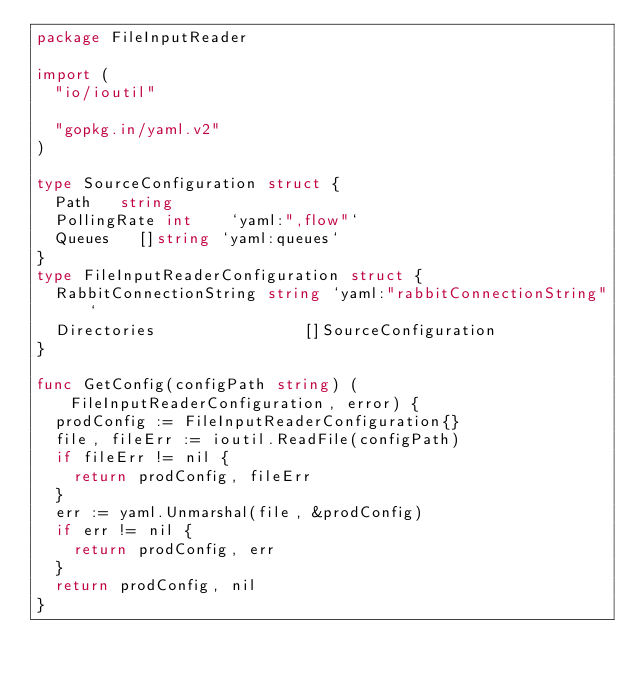<code> <loc_0><loc_0><loc_500><loc_500><_Go_>package FileInputReader

import (
	"io/ioutil"

	"gopkg.in/yaml.v2"
)

type SourceConfiguration struct {
	Path   string
	PollingRate int    `yaml:",flow"`
	Queues   []string `yaml:queues`
}
type FileInputReaderConfiguration struct {
	RabbitConnectionString string `yaml:"rabbitConnectionString"`
	Directories                []SourceConfiguration
}

func GetConfig(configPath string) (FileInputReaderConfiguration, error) {
	prodConfig := FileInputReaderConfiguration{}
	file, fileErr := ioutil.ReadFile(configPath)
	if fileErr != nil {
		return prodConfig, fileErr
	}
	err := yaml.Unmarshal(file, &prodConfig)
	if err != nil {
		return prodConfig, err
	}
	return prodConfig, nil
}
</code> 